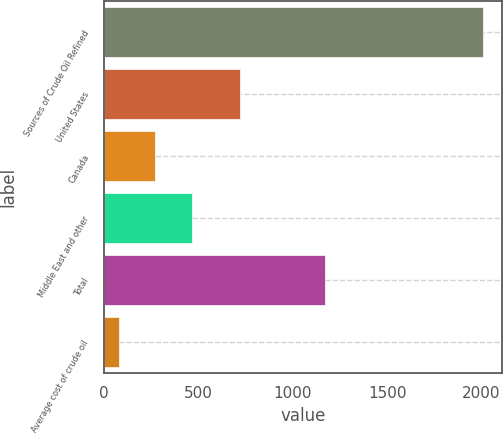Convert chart. <chart><loc_0><loc_0><loc_500><loc_500><bar_chart><fcel>Sources of Crude Oil Refined<fcel>United States<fcel>Canada<fcel>Middle East and other<fcel>Total<fcel>Average cost of crude oil<nl><fcel>2010<fcel>720<fcel>271.71<fcel>464.85<fcel>1173<fcel>78.57<nl></chart> 